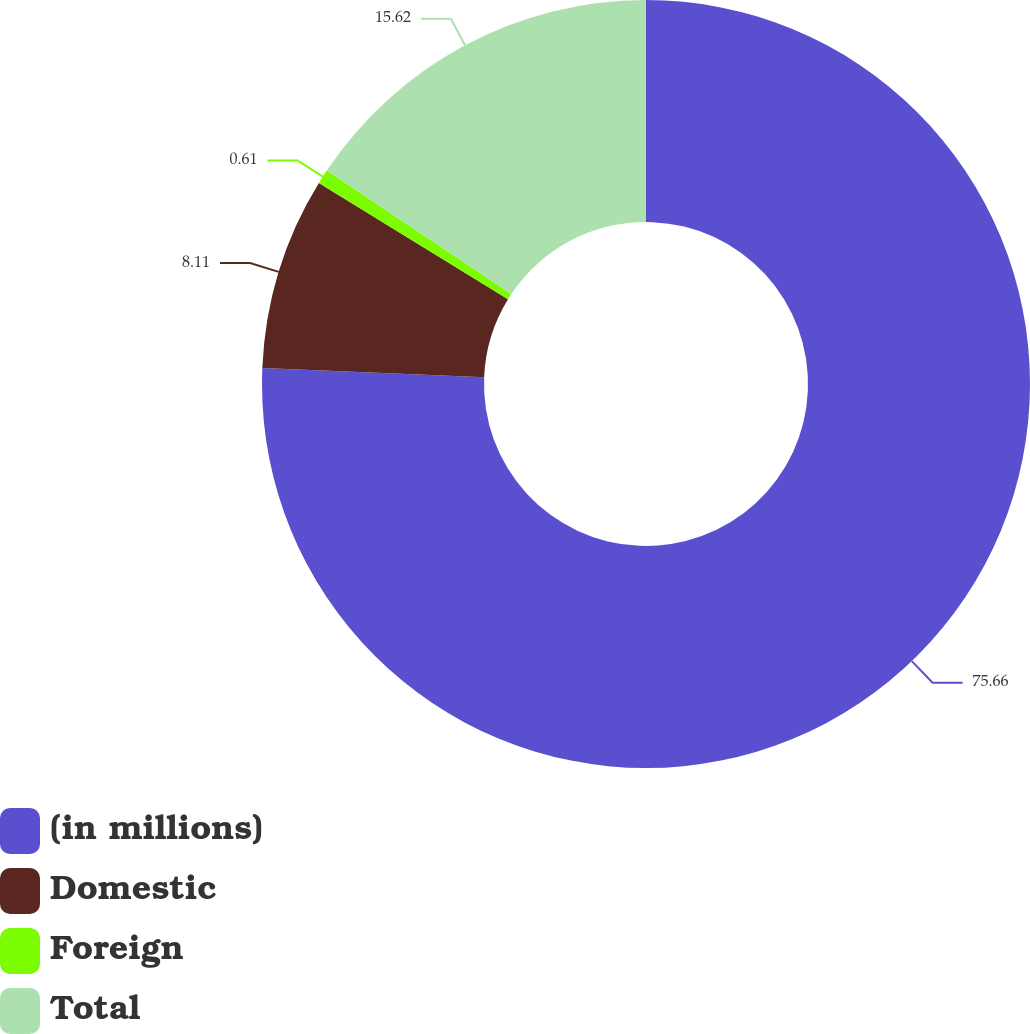Convert chart. <chart><loc_0><loc_0><loc_500><loc_500><pie_chart><fcel>(in millions)<fcel>Domestic<fcel>Foreign<fcel>Total<nl><fcel>75.67%<fcel>8.11%<fcel>0.61%<fcel>15.62%<nl></chart> 